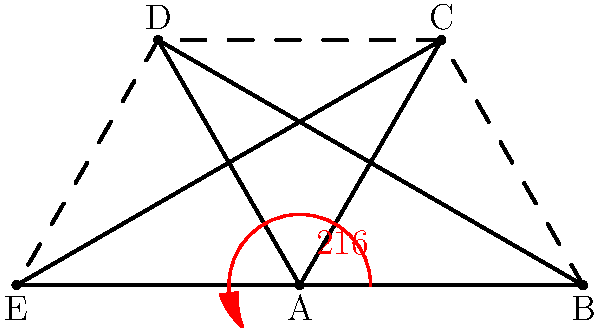In this poorly constructed star shape, identify the reflex angle at point A and calculate its exact measure. Your answer should demonstrate a thorough understanding of geometry principles that any competent primary school student should possess. To solve this problem, we must follow these rigorous steps:

1) First, recall that a reflex angle is an angle greater than 180° but less than 360°.

2) In a regular five-pointed star, each point would have an angle of 36°. However, this is clearly not a regular star.

3) Observe that the star is made up of 5 triangles. In any triangle, the sum of interior angles is always 180°.

4) The reflex angle at A is the "outside" angle. It's supplementary to the interior angle at A.

5) The interior angle at A plus the reflex angle at A must sum to 360°.

6) We can see that the reflex angle is labeled as 216°.

7) To verify: 
   $360° - 216° = 144°$
   This 144° would be the measure of the interior angle at A.

8) 144° is indeed less than 180°, confirming that 216° is the reflex angle.

Therefore, the reflex angle at point A measures exactly 216°. This level of geometric analysis should be second nature to any well-educated primary school student.
Answer: 216° 